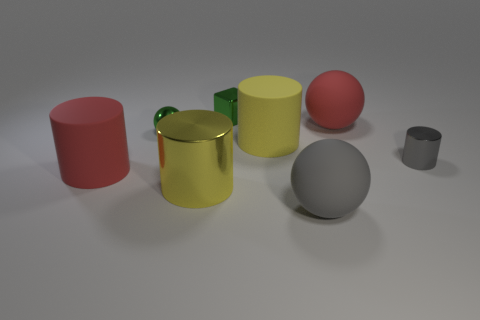Can you describe the lighting in the scene and how it affects the appearance of the objects? The lighting in the scene seems to be diffuse, with possibly a soft box light source positioned above the scene. This creates a soft shadow on the ground beneath each object, allowing their colors and shapes to be gently accentuated without harsh contrasts. The specular highlights on the yellow and green cylinders suggest a somewhat reflective material, yet not as lustrous as the tiny metal cylinder. 